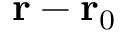<formula> <loc_0><loc_0><loc_500><loc_500>r - r _ { 0 }</formula> 